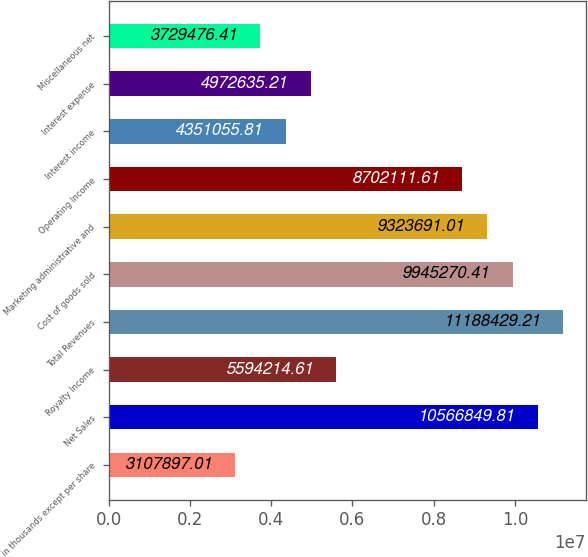Convert chart to OTSL. <chart><loc_0><loc_0><loc_500><loc_500><bar_chart><fcel>in thousands except per share<fcel>Net Sales<fcel>Royalty Income<fcel>Total Revenues<fcel>Cost of goods sold<fcel>Marketing administrative and<fcel>Operating Income<fcel>Interest income<fcel>Interest expense<fcel>Miscellaneous net<nl><fcel>3.1079e+06<fcel>1.05668e+07<fcel>5.59421e+06<fcel>1.11884e+07<fcel>9.94527e+06<fcel>9.32369e+06<fcel>8.70211e+06<fcel>4.35106e+06<fcel>4.97264e+06<fcel>3.72948e+06<nl></chart> 